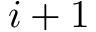<formula> <loc_0><loc_0><loc_500><loc_500>i + 1</formula> 